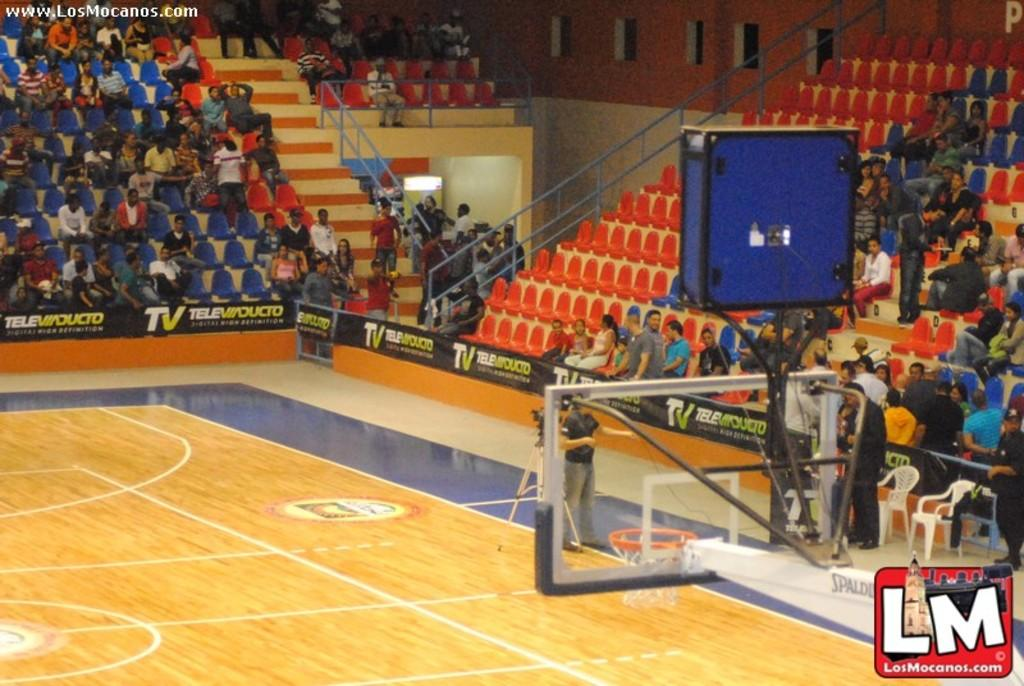<image>
Write a terse but informative summary of the picture. fans are waiting in the stadium for the basketball game to start which is sponsored by TeleViaDucto 